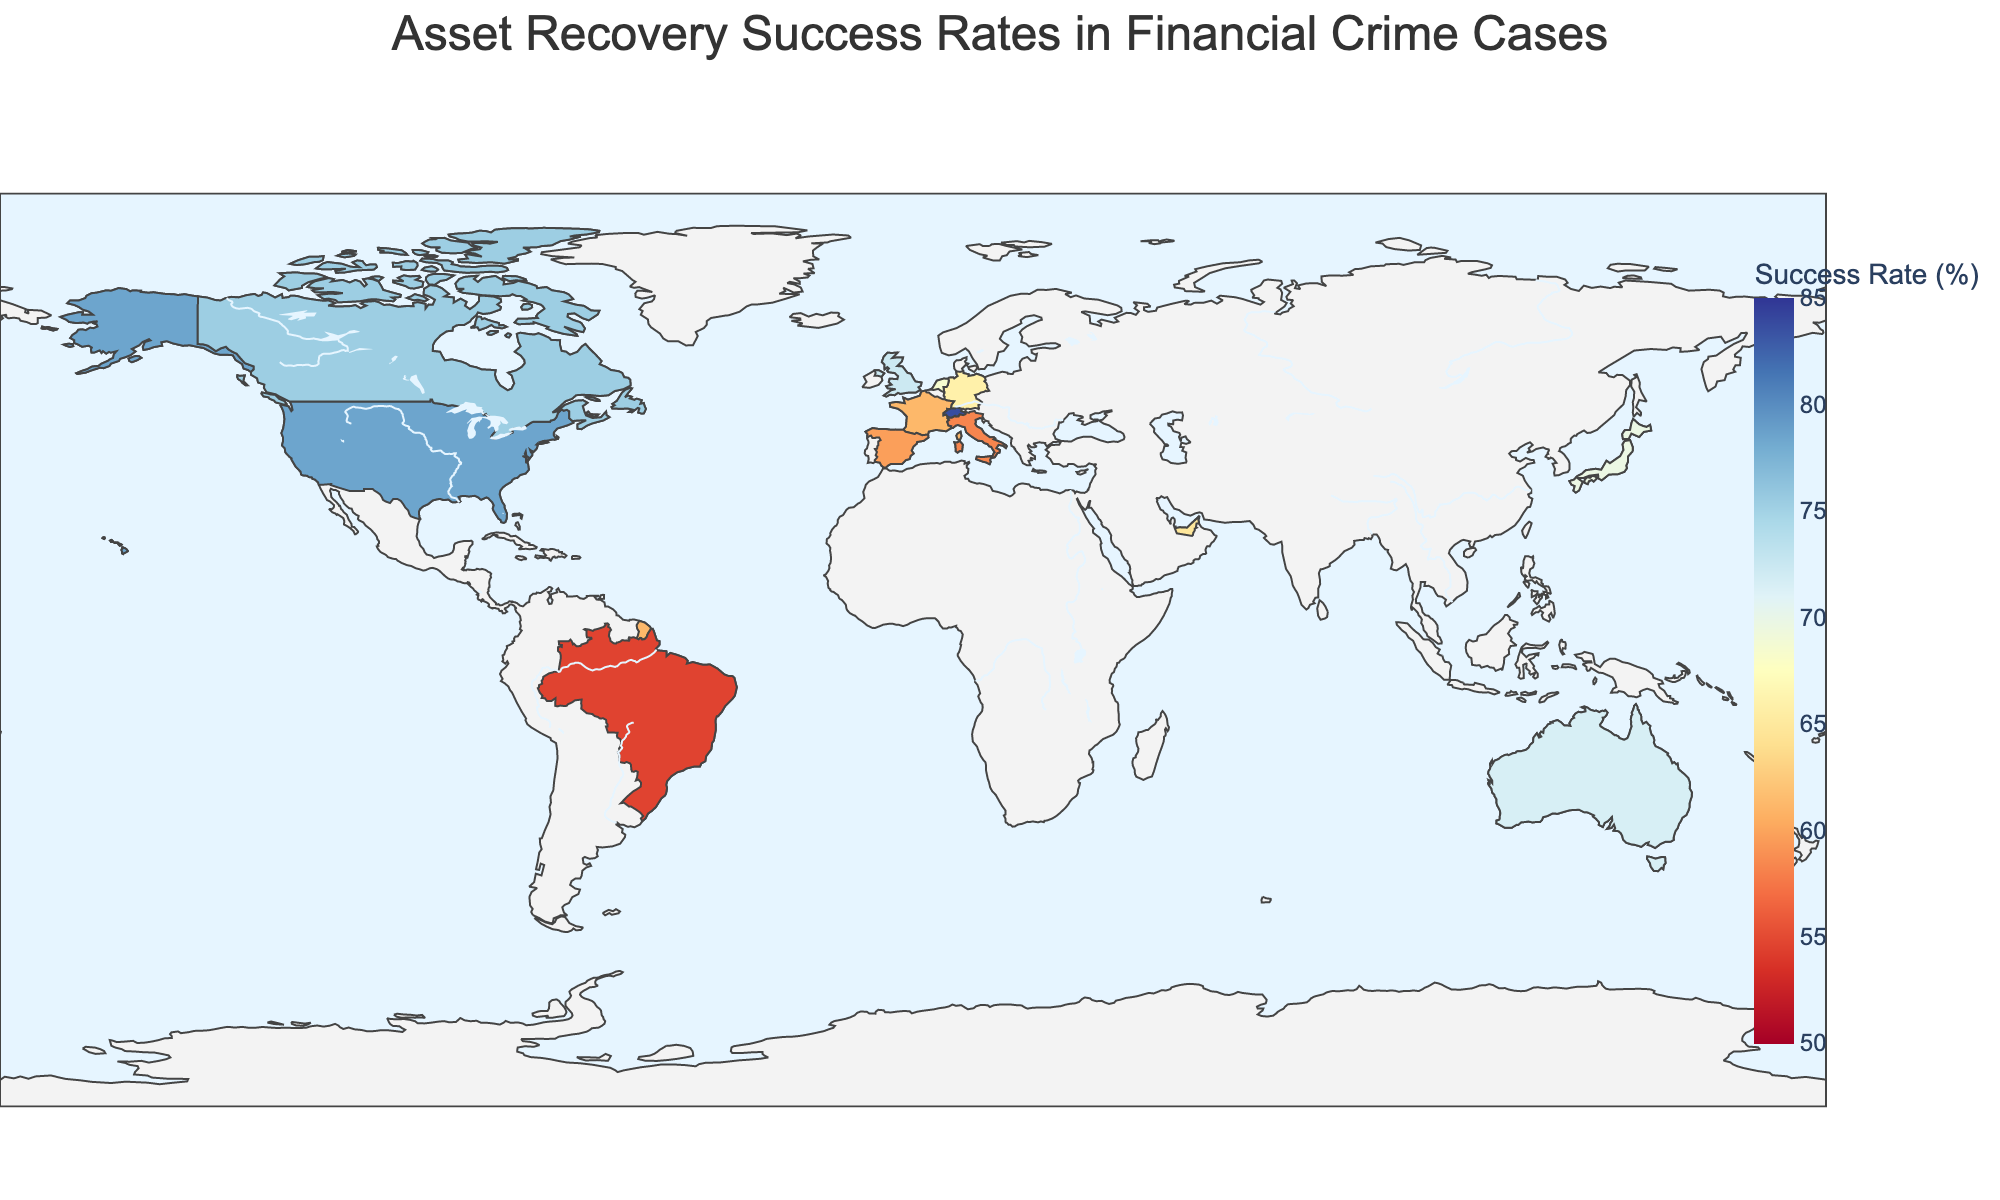What's the title of the figure? The title is typically placed at the top center of the figure. It provides a summary of what the figure is about.
Answer: Asset Recovery Success Rates in Financial Crime Cases What color scale is used in the figure? The color scale in the figure uses varying shades to represent different success rates, making it easier to visually interpret different data points.
Answer: Red-Yellow-Blue Which country has the highest asset recovery success rate? By examining all the countries' success rates, Switzerland has the highest percentage.
Answer: Switzerland How many countries are represented in the plot? The plot includes one data point per country, counting all unique country names gives us the total number.
Answer: 15 What's the range of success rates displayed on the color bar? The color bar on the side of the map indicates the minimum and maximum values shown on the plot.
Answer: 50% to 85% What is the difference in success rates between the United States and Brazil? Subtract Brazil's success rate from the United States' rate: 78.5% - 54.6%.
Answer: 23.9% Which countries have a mixed legal system and what are their success rates? The hover data or legend provides information about the legal system. We identify the mixed system countries and note their success rates.
Answer: Singapore (80.1%), United Arab Emirates (64.8%) Which common law country has the lowest success rate? From the countries listed with the common law system, we find the one with the smallest success rate.
Answer: Australia What's the average asset recovery success rate for civil law countries? Sum the success rates of civil law countries and divide by the number of those countries. (65.9 + 61.2 + 83.7 + 54.6 + 69.8 + 58.3 + 59.7 + 68.5) / 8
Answer: 65.21% How does the success rate of Germany compare to Japan? Compare the success rates of the two countries by checking their respective values.
Answer: Germany has a slightly lower rate than Japan 